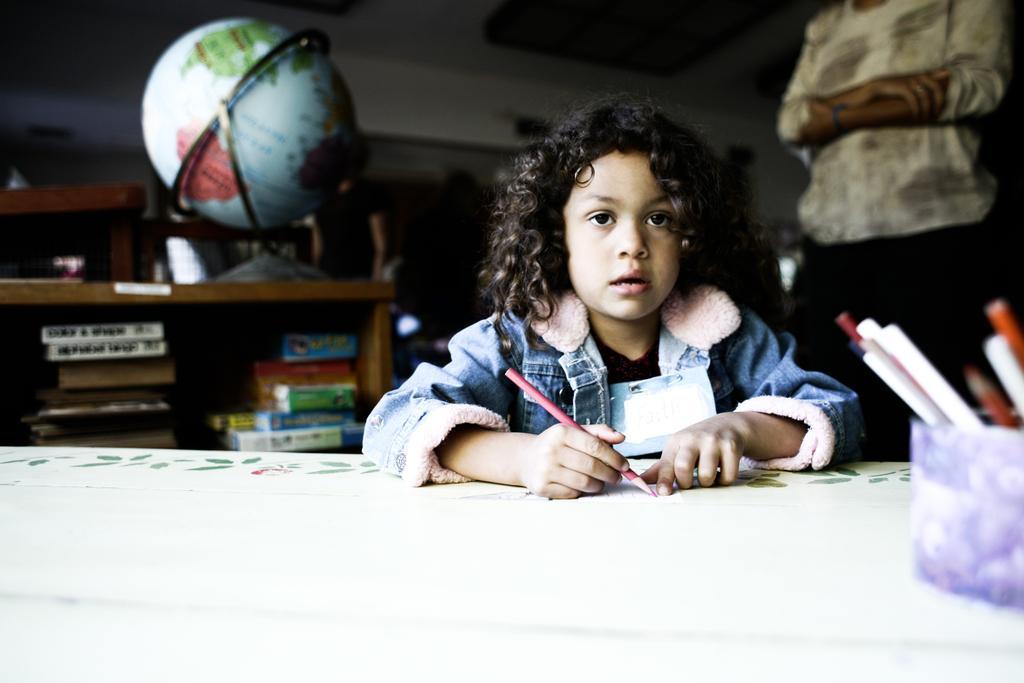Could you give a brief overview of what you see in this image? In the center we can see one person sitting and holding pencil. In the background there is a wall and one more person standing. 